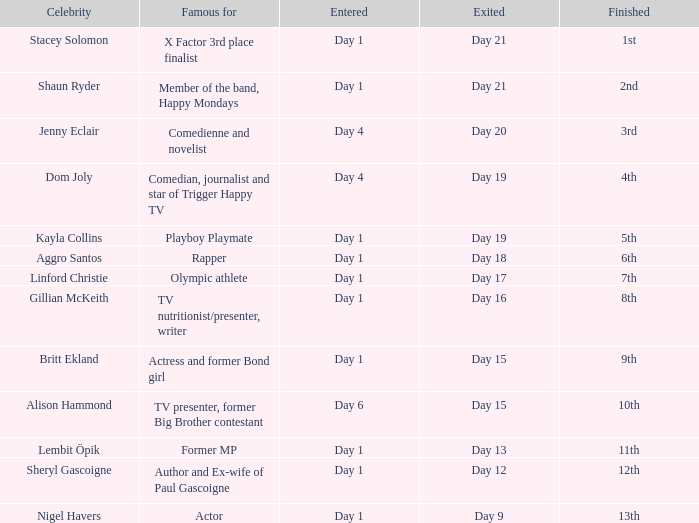In which place did the famous person who entered on the first day and left on the 15th day end up? 9th. 